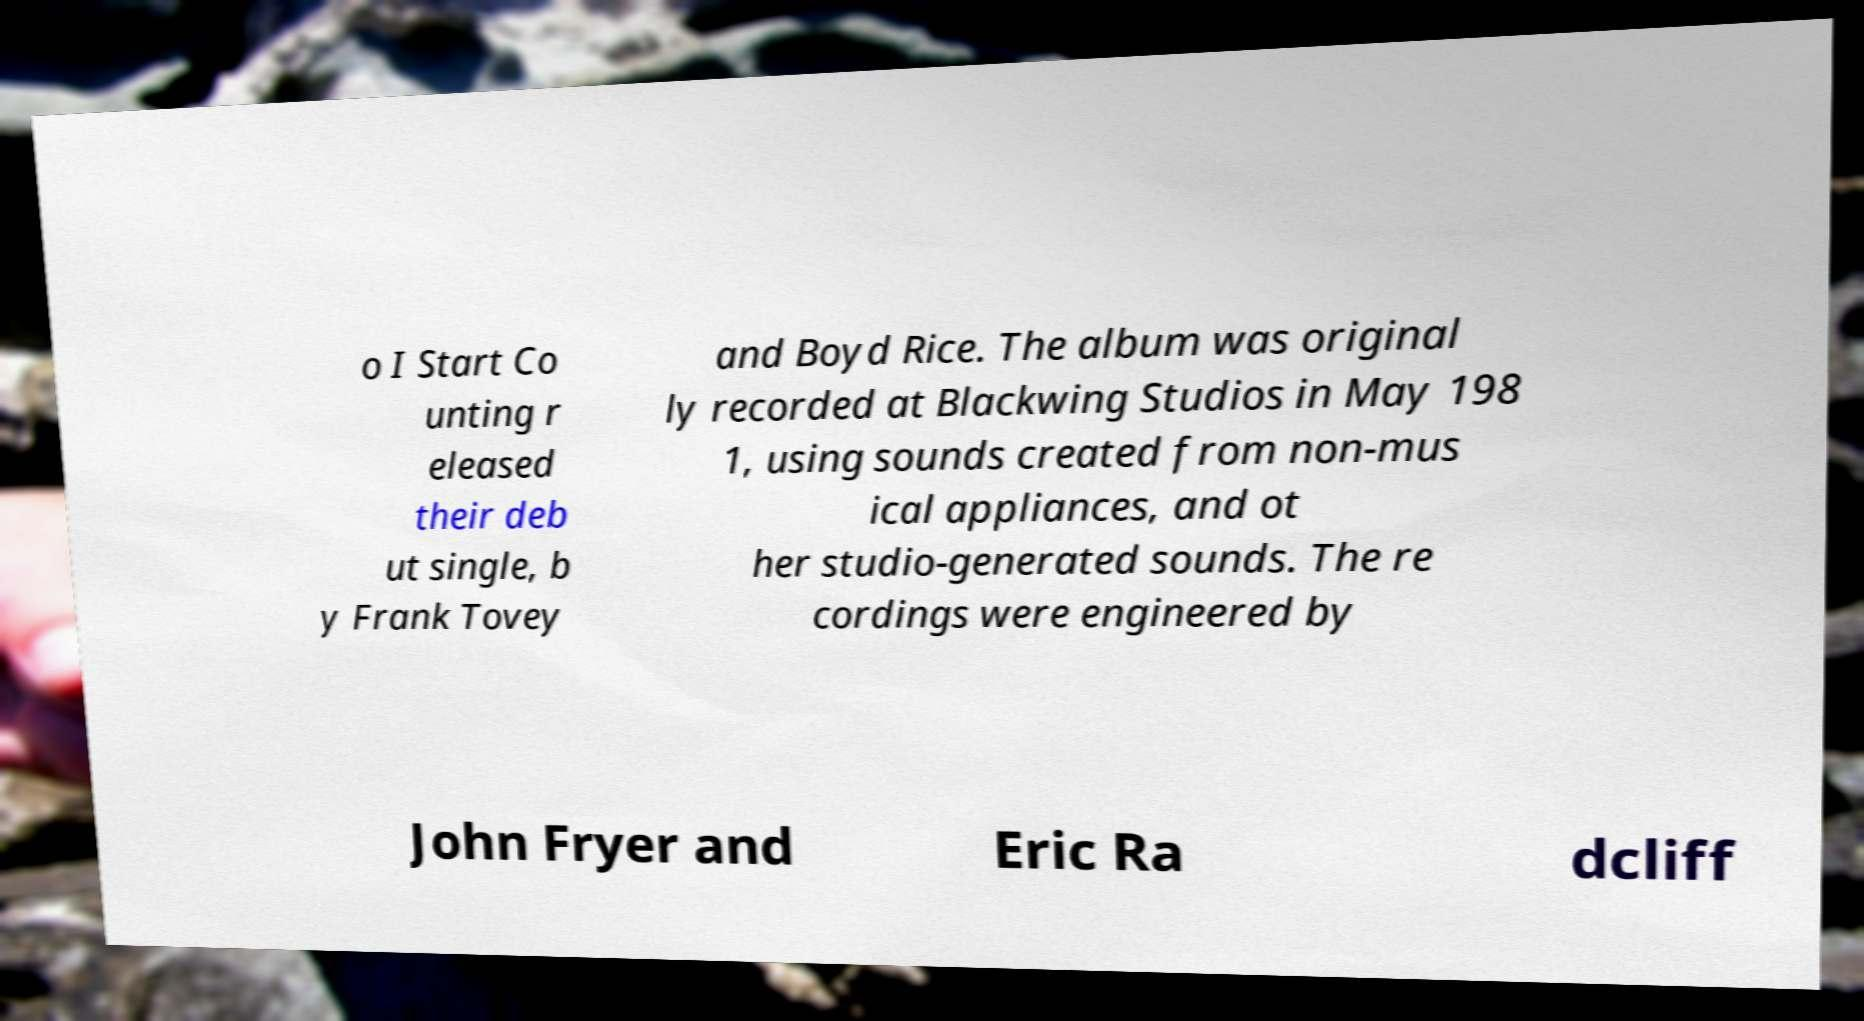Can you read and provide the text displayed in the image?This photo seems to have some interesting text. Can you extract and type it out for me? o I Start Co unting r eleased their deb ut single, b y Frank Tovey and Boyd Rice. The album was original ly recorded at Blackwing Studios in May 198 1, using sounds created from non-mus ical appliances, and ot her studio-generated sounds. The re cordings were engineered by John Fryer and Eric Ra dcliff 